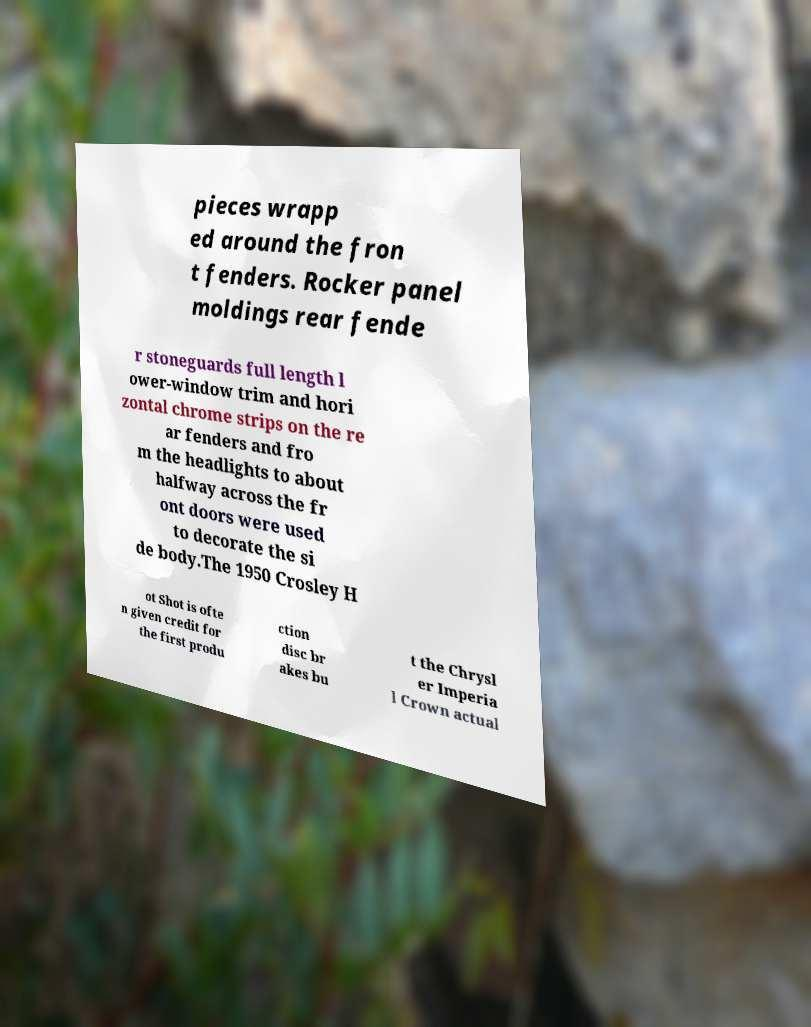I need the written content from this picture converted into text. Can you do that? pieces wrapp ed around the fron t fenders. Rocker panel moldings rear fende r stoneguards full length l ower-window trim and hori zontal chrome strips on the re ar fenders and fro m the headlights to about halfway across the fr ont doors were used to decorate the si de body.The 1950 Crosley H ot Shot is ofte n given credit for the first produ ction disc br akes bu t the Chrysl er Imperia l Crown actual 